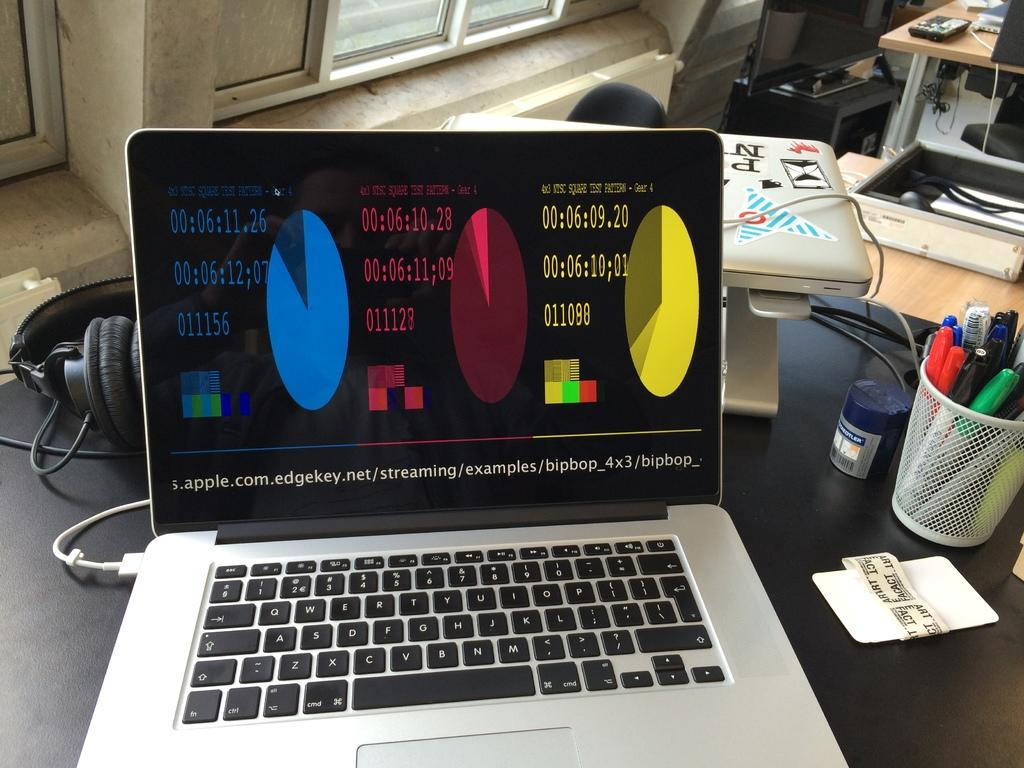What piece of furniture is present in the image? There is a table in the image. What electronic devices are on the table? There are laptops on the table. What writing instruments are on the table? There are pens on the table. What communication device is on the table? There is a headset on the table. Where is the maid located in the image? There is no maid present in the image. What direction is the north represented in the image? The image does not depict a compass or any indication of direction, so it is not possible to determine the location of the north. 